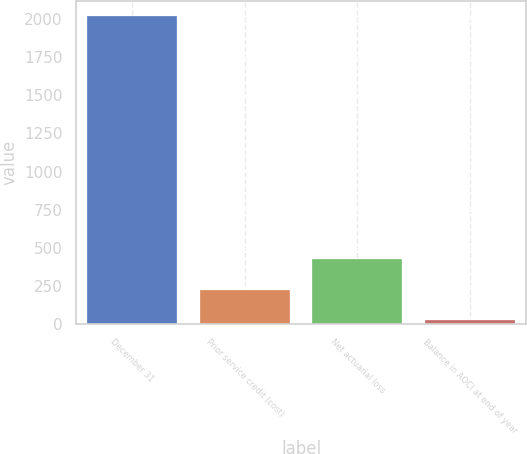<chart> <loc_0><loc_0><loc_500><loc_500><bar_chart><fcel>December 31<fcel>Prior service credit (cost)<fcel>Net actuarial loss<fcel>Balance in AOCI at end of year<nl><fcel>2017<fcel>225.1<fcel>424.2<fcel>26<nl></chart> 